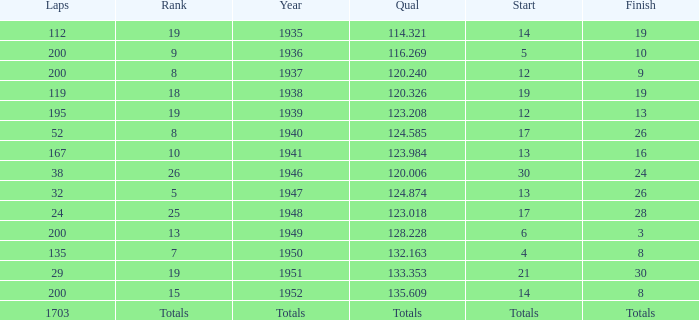In 1937, what was the finish? 9.0. 